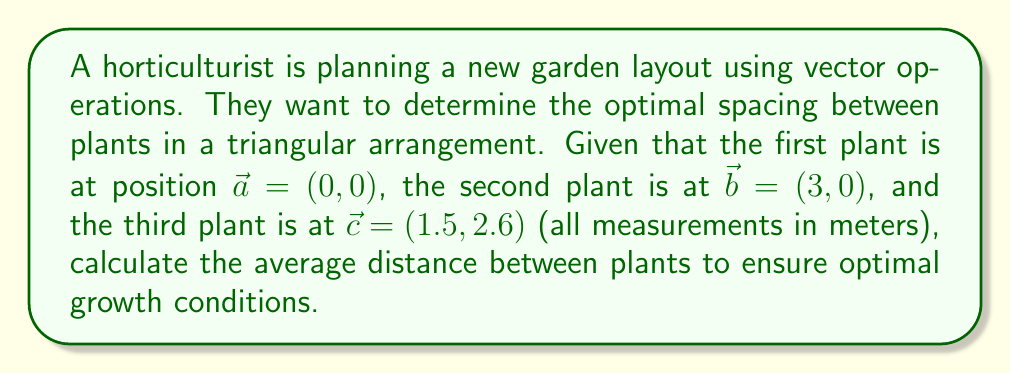Give your solution to this math problem. To solve this problem, we'll use vector operations to find the distances between plants and then calculate the average.

1. Calculate the vectors between plants:
   $\vec{ab} = \vec{b} - \vec{a} = (3, 0) - (0, 0) = (3, 0)$
   $\vec{bc} = \vec{c} - \vec{b} = (1.5, 2.6) - (3, 0) = (-1.5, 2.6)$
   $\vec{ca} = \vec{a} - \vec{c} = (0, 0) - (1.5, 2.6) = (-1.5, -2.6)$

2. Calculate the magnitude (length) of each vector:
   $|\vec{ab}| = \sqrt{3^2 + 0^2} = 3$
   $|\vec{bc}| = \sqrt{(-1.5)^2 + 2.6^2} = \sqrt{2.25 + 6.76} = \sqrt{9.01} \approx 3.002$
   $|\vec{ca}| = \sqrt{(-1.5)^2 + (-2.6)^2} = \sqrt{2.25 + 6.76} = \sqrt{9.01} \approx 3.002$

3. Calculate the average distance:
   Average distance = $\frac{|\vec{ab}| + |\vec{bc}| + |\vec{ca}|}{3}$
                    $\approx \frac{3 + 3.002 + 3.002}{3}$
                    $\approx \frac{9.004}{3}$
                    $\approx 3.001$ meters
Answer: The average distance between plants for optimal spacing is approximately 3.001 meters. 